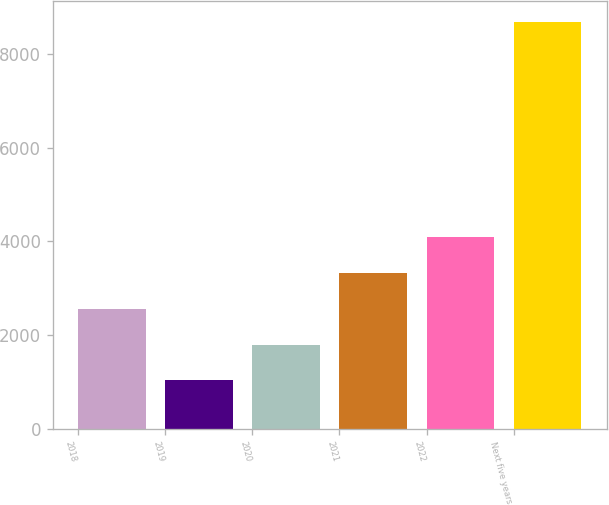Convert chart. <chart><loc_0><loc_0><loc_500><loc_500><bar_chart><fcel>2018<fcel>2019<fcel>2020<fcel>2021<fcel>2022<fcel>Next five years<nl><fcel>2563.8<fcel>1032<fcel>1797.9<fcel>3329.7<fcel>4095.6<fcel>8691<nl></chart> 